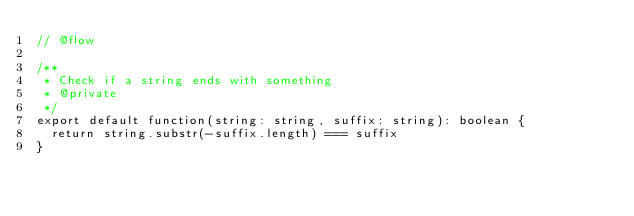Convert code to text. <code><loc_0><loc_0><loc_500><loc_500><_JavaScript_>// @flow

/**
 * Check if a string ends with something
 * @private
 */
export default function(string: string, suffix: string): boolean {
  return string.substr(-suffix.length) === suffix
}
</code> 